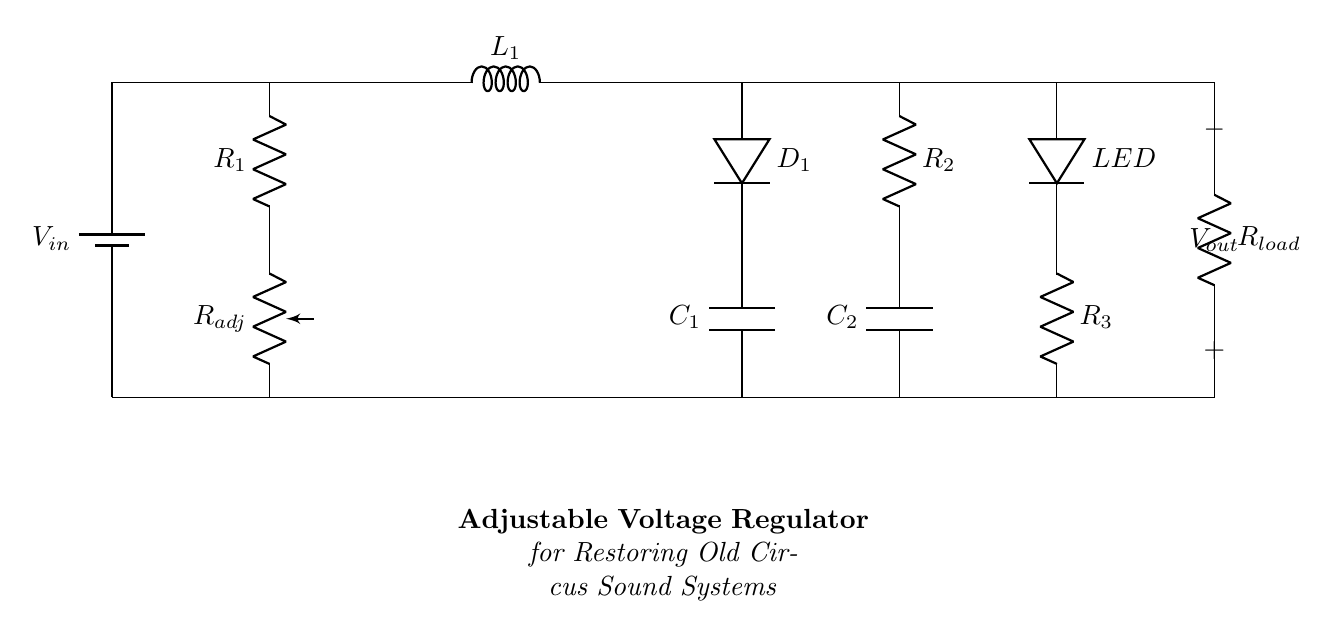What is the input voltage labeled in the circuit? The input voltage is labeled as V_in, which represents the voltage supplied to the circuit.
Answer: V_in What component adjusts the output voltage? The component that adjusts the output voltage is the potentiometer labeled R_adj. It is a variable resistor that allows the user to set the desired output voltage.
Answer: R_adj How many resistors are in this circuit? There are three resistors labeled R_1, R_2, and R_3 within the circuit diagram.
Answer: 3 Which component indicates when the circuit is powered on? The component that indicates when the circuit is powered on is the LED, which lights up to show that the circuit is functioning correctly.
Answer: LED What is the primary function of the capacitor in this circuit? The primary function of the capacitors C_1 and C_2 in this circuit is to filter and smooth the output voltage, reducing fluctuations and ensuring stable operation.
Answer: Smooth output voltage What happens to the output voltage if the R_adj is increased? Increasing R_adj raises the resistance, which typically reduces the current flowing through the circuit, resulting in a higher output voltage according to the voltage divider principle.
Answer: Higher output voltage 